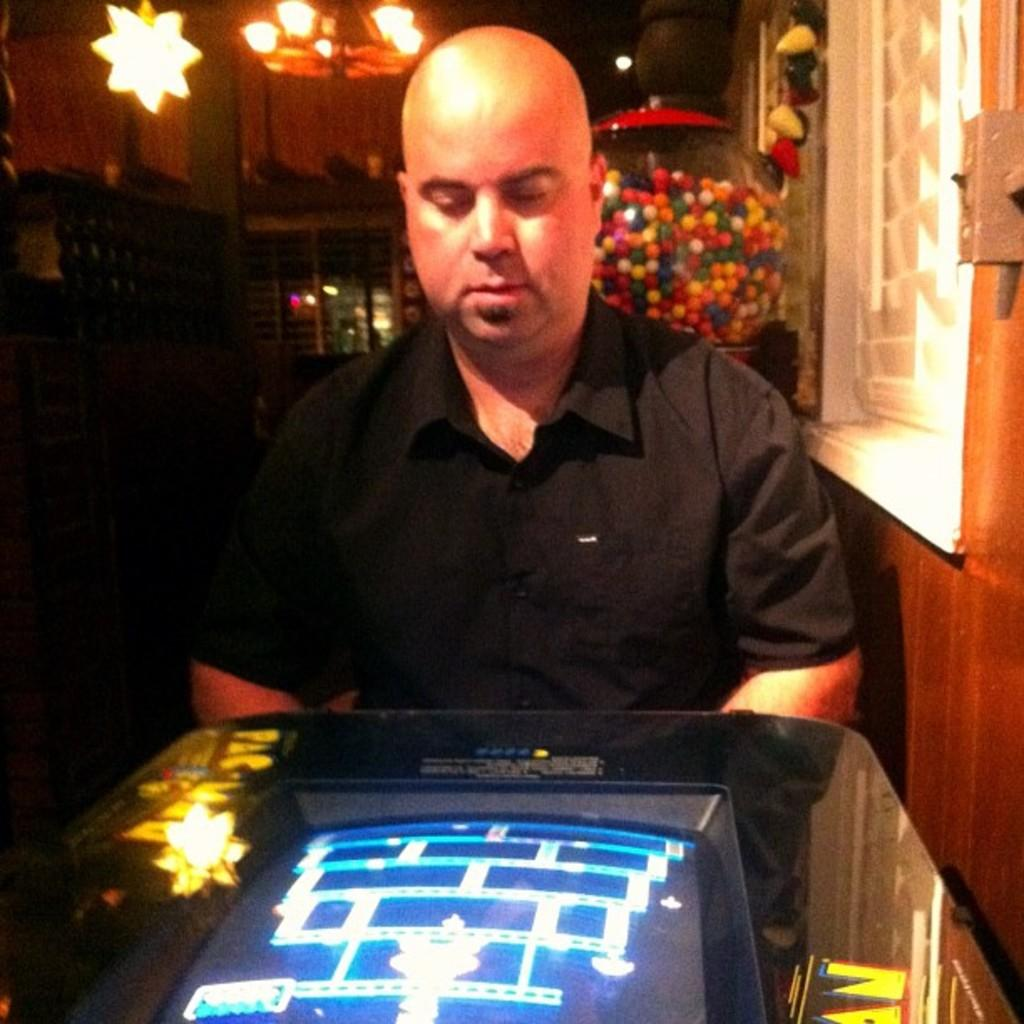What is the person in the image wearing? The person in the image is wearing a black dress. What is in front of the person? There is a screen in front of the person. What can be seen in the background of the image? There are lights and a glass pot visible in the background. What is inside the glass pot? There are balls in the glass pot. What is the condition of the person's wrist in the image? There is no information about the person's wrist in the image, so we cannot determine its condition. 